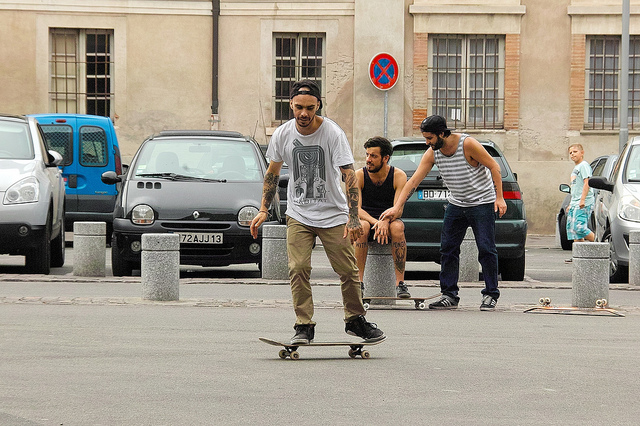Identify the text displayed in this image. 172AJJ13 